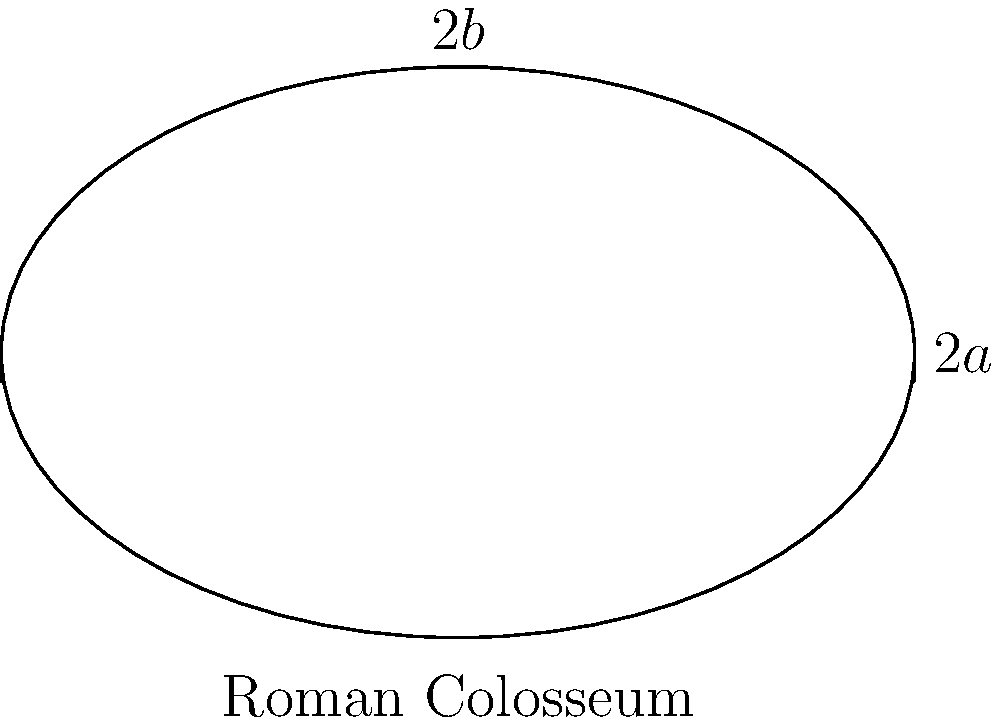As a political science student with an interest in history, you're studying the architecture of ancient Rome. The Roman Colosseum can be approximated as an ellipse. If the major axis of this elliptical shape is 188 meters and the minor axis is 156 meters, calculate:

a) The perimeter of the Colosseum (use the approximation formula $P \approx 2\pi\sqrt{\frac{a^2 + b^2}{2}}$, where $a$ and $b$ are the semi-major and semi-minor axes)
b) The area of the arena floor

Round your answers to the nearest whole number. Let's approach this step-by-step:

1) First, we need to identify the semi-major (a) and semi-minor (b) axes:
   $a = 188/2 = 94$ meters
   $b = 156/2 = 78$ meters

2) For the perimeter:
   We'll use the formula $P \approx 2\pi\sqrt{\frac{a^2 + b^2}{2}}$
   
   $P \approx 2\pi\sqrt{\frac{94^2 + 78^2}{2}}$
   $\approx 2\pi\sqrt{\frac{8836 + 6084}{2}}$
   $\approx 2\pi\sqrt{7460}$
   $\approx 2\pi * 86.37$
   $\approx 542.5$ meters

   Rounded to the nearest whole number: 543 meters

3) For the area:
   We'll use the formula for the area of an ellipse: $A = \pi ab$
   
   $A = \pi * 94 * 78$
   $\approx 23,014$ square meters

   Rounded to the nearest whole number: 23,014 square meters

This problem connects your interest in Roman history with mathematical concepts, demonstrating how ancient structures can be analyzed using geometric principles.
Answer: a) 543 meters
b) 23,014 square meters 